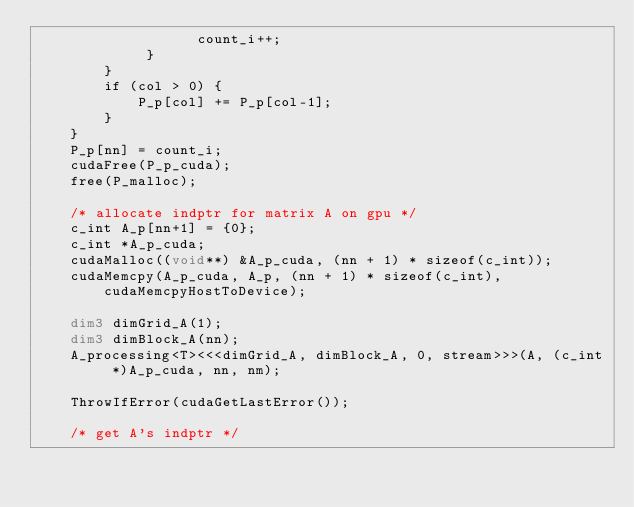<code> <loc_0><loc_0><loc_500><loc_500><_Cuda_>	               count_i++;
	         }
	    }
	    if (col > 0) {
			P_p[col] += P_p[col-1];
		}
	}
	P_p[nn] = count_i;
	cudaFree(P_p_cuda);
	free(P_malloc);

	/* allocate indptr for matrix A on gpu */
	c_int A_p[nn+1] = {0};
	c_int *A_p_cuda;
	cudaMalloc((void**) &A_p_cuda, (nn + 1) * sizeof(c_int));
	cudaMemcpy(A_p_cuda, A_p, (nn + 1) * sizeof(c_int), cudaMemcpyHostToDevice);

    dim3 dimGrid_A(1);
    dim3 dimBlock_A(nn);
    A_processing<T><<<dimGrid_A, dimBlock_A, 0, stream>>>(A, (c_int *)A_p_cuda, nn, nm);

    ThrowIfError(cudaGetLastError());

    /* get A's indptr */</code> 